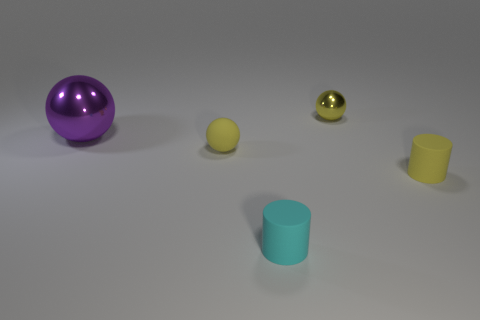Subtract all yellow cylinders. How many yellow spheres are left? 2 Subtract all tiny balls. How many balls are left? 1 Add 4 cyan cylinders. How many objects exist? 9 Add 4 green metal things. How many green metal things exist? 4 Subtract 2 yellow balls. How many objects are left? 3 Subtract all spheres. How many objects are left? 2 Subtract all tiny yellow balls. Subtract all rubber cylinders. How many objects are left? 1 Add 5 large purple shiny things. How many large purple shiny things are left? 6 